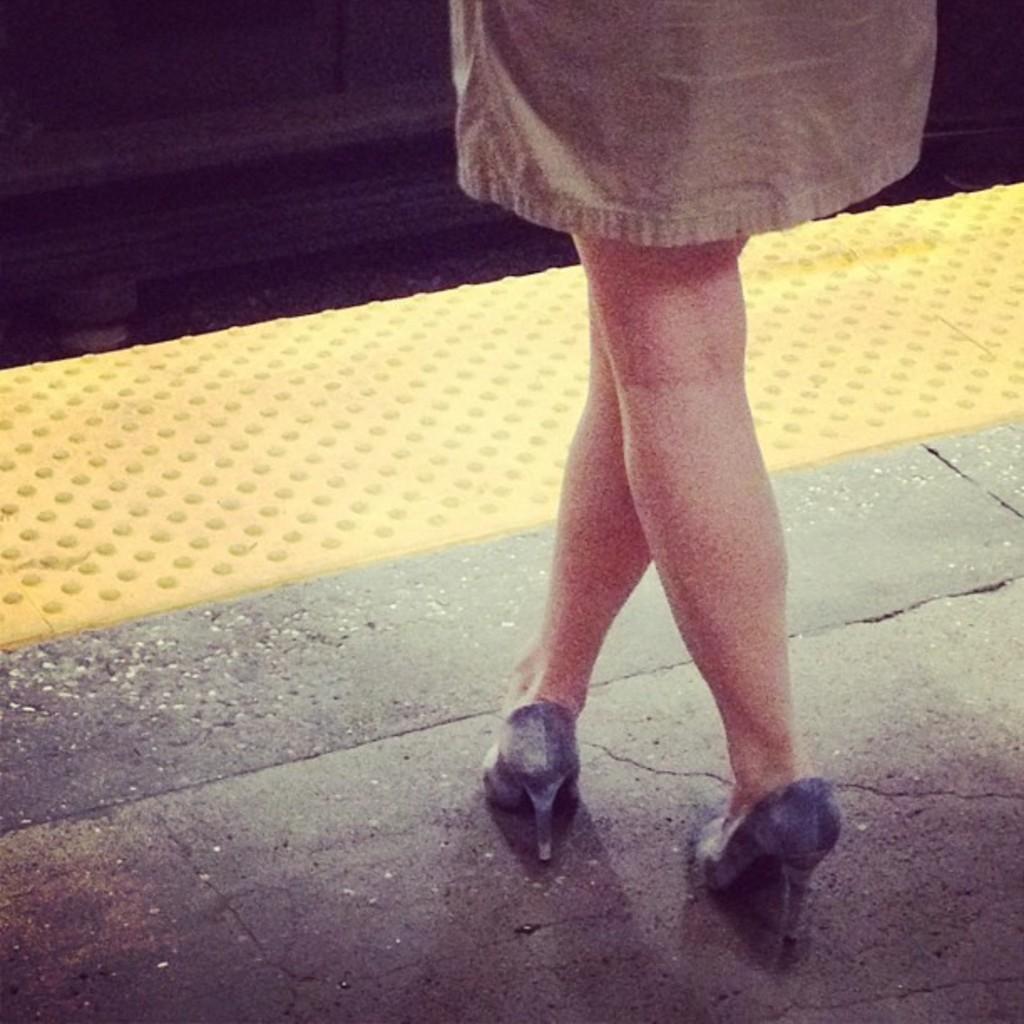In one or two sentences, can you explain what this image depicts? In this picture I can see legs of a human and she is wearing foot wear. 